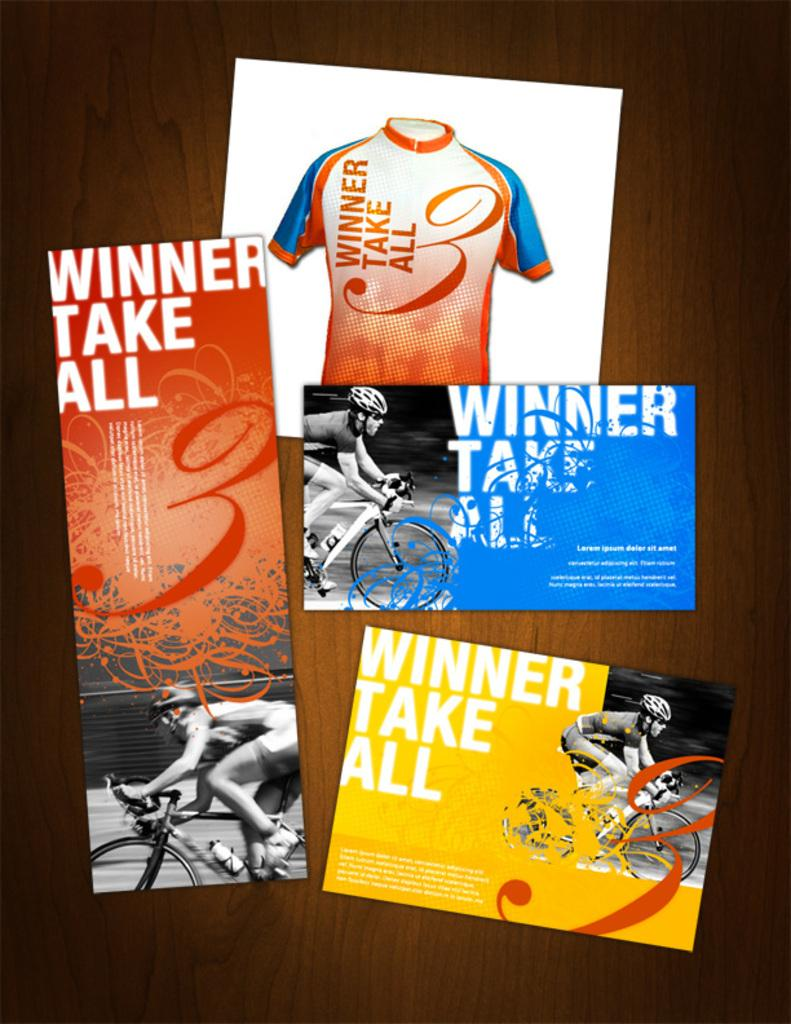<image>
Offer a succinct explanation of the picture presented. A mixture of "winner take all" designs are on the table. 